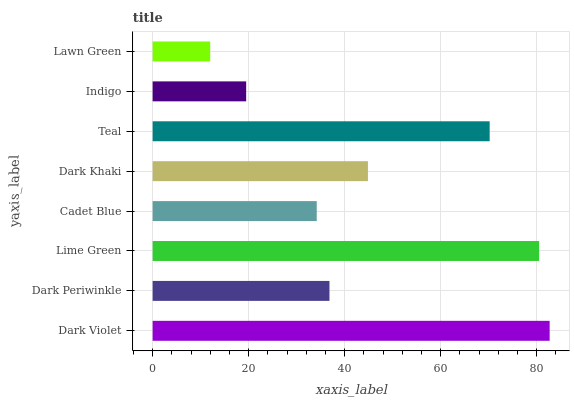Is Lawn Green the minimum?
Answer yes or no. Yes. Is Dark Violet the maximum?
Answer yes or no. Yes. Is Dark Periwinkle the minimum?
Answer yes or no. No. Is Dark Periwinkle the maximum?
Answer yes or no. No. Is Dark Violet greater than Dark Periwinkle?
Answer yes or no. Yes. Is Dark Periwinkle less than Dark Violet?
Answer yes or no. Yes. Is Dark Periwinkle greater than Dark Violet?
Answer yes or no. No. Is Dark Violet less than Dark Periwinkle?
Answer yes or no. No. Is Dark Khaki the high median?
Answer yes or no. Yes. Is Dark Periwinkle the low median?
Answer yes or no. Yes. Is Cadet Blue the high median?
Answer yes or no. No. Is Indigo the low median?
Answer yes or no. No. 